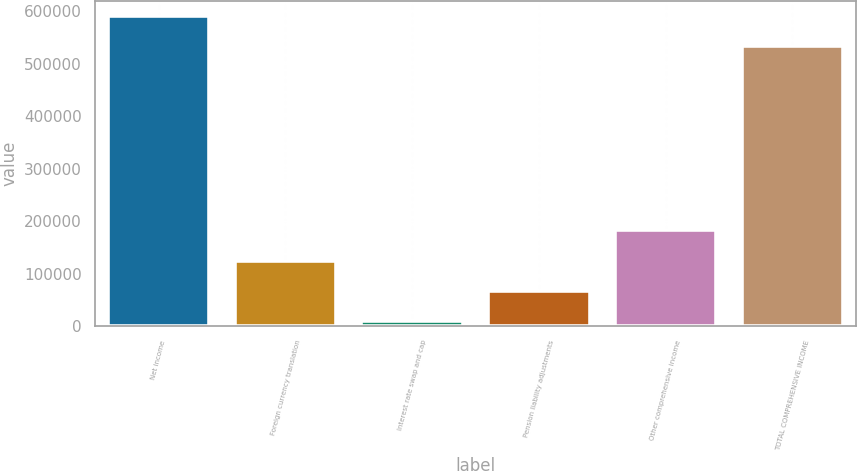<chart> <loc_0><loc_0><loc_500><loc_500><bar_chart><fcel>Net income<fcel>Foreign currency translation<fcel>Interest rate swap and cap<fcel>Pension liability adjustments<fcel>Other comprehensive income<fcel>TOTAL COMPREHENSIVE INCOME<nl><fcel>590313<fcel>125001<fcel>9648<fcel>67324.6<fcel>182678<fcel>532636<nl></chart> 